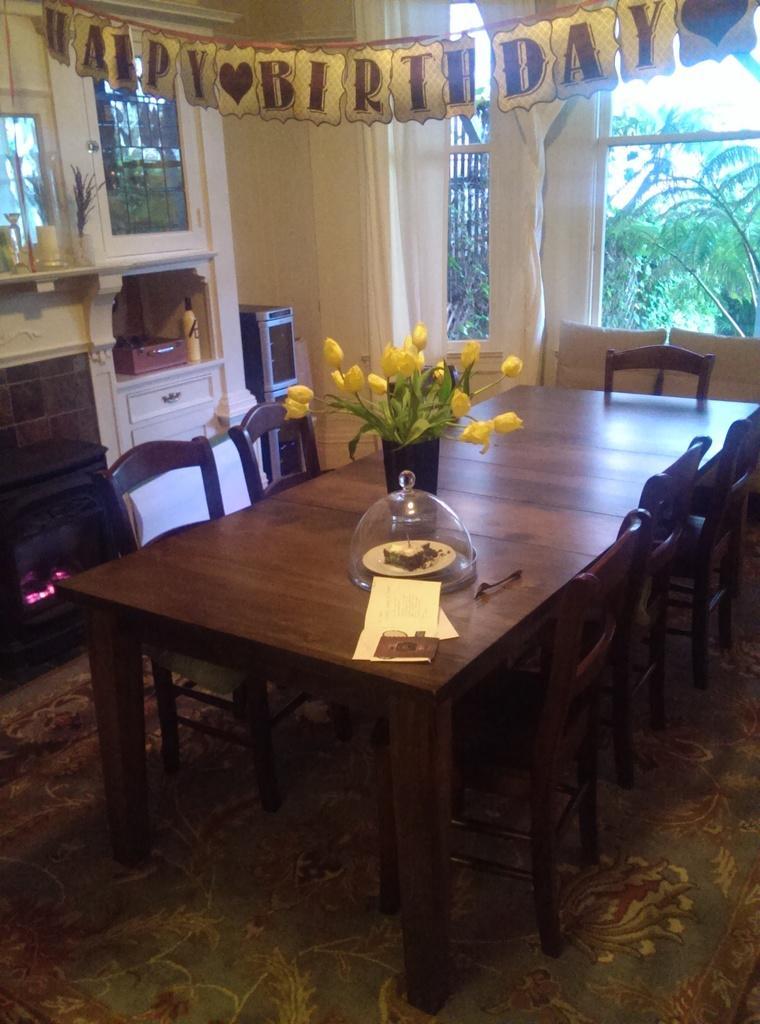How would you summarize this image in a sentence or two? In the image we can see there are chairs and a table. On the table, there is a flower bookey, plate and food on the plate, this is a paper, floor, cupboards, objects, fence, text and a window. Out of the window we can see there are many trees. 